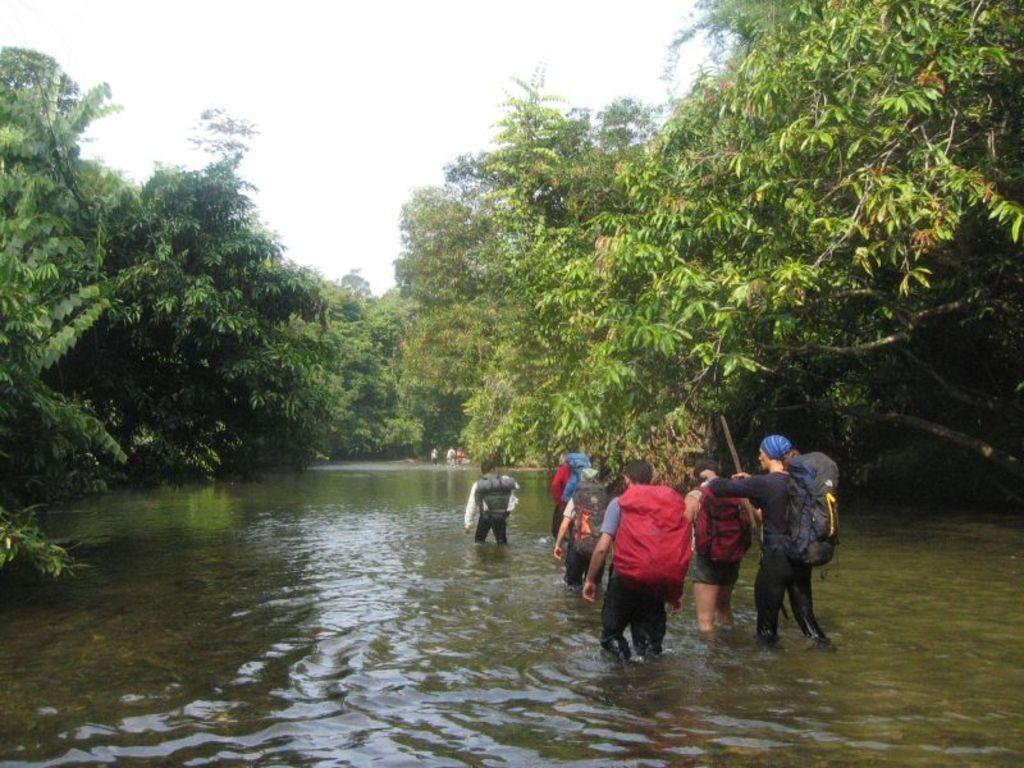What can be seen in the sky in the image? The sky is visible in the image. What type of vegetation is present in the image? There are trees in the image. What are the people in the image wearing? The people appear to be wearing bags in the image. What are the people in the image doing? The people appear to be walking in the image. What else is visible in the image besides the sky and trees? There is water visible in the image. How many pies are being served at the birthday party in the image? There is no birthday party or pies present in the image. What cast is performing in the image? There is no cast or performance present in the image. 